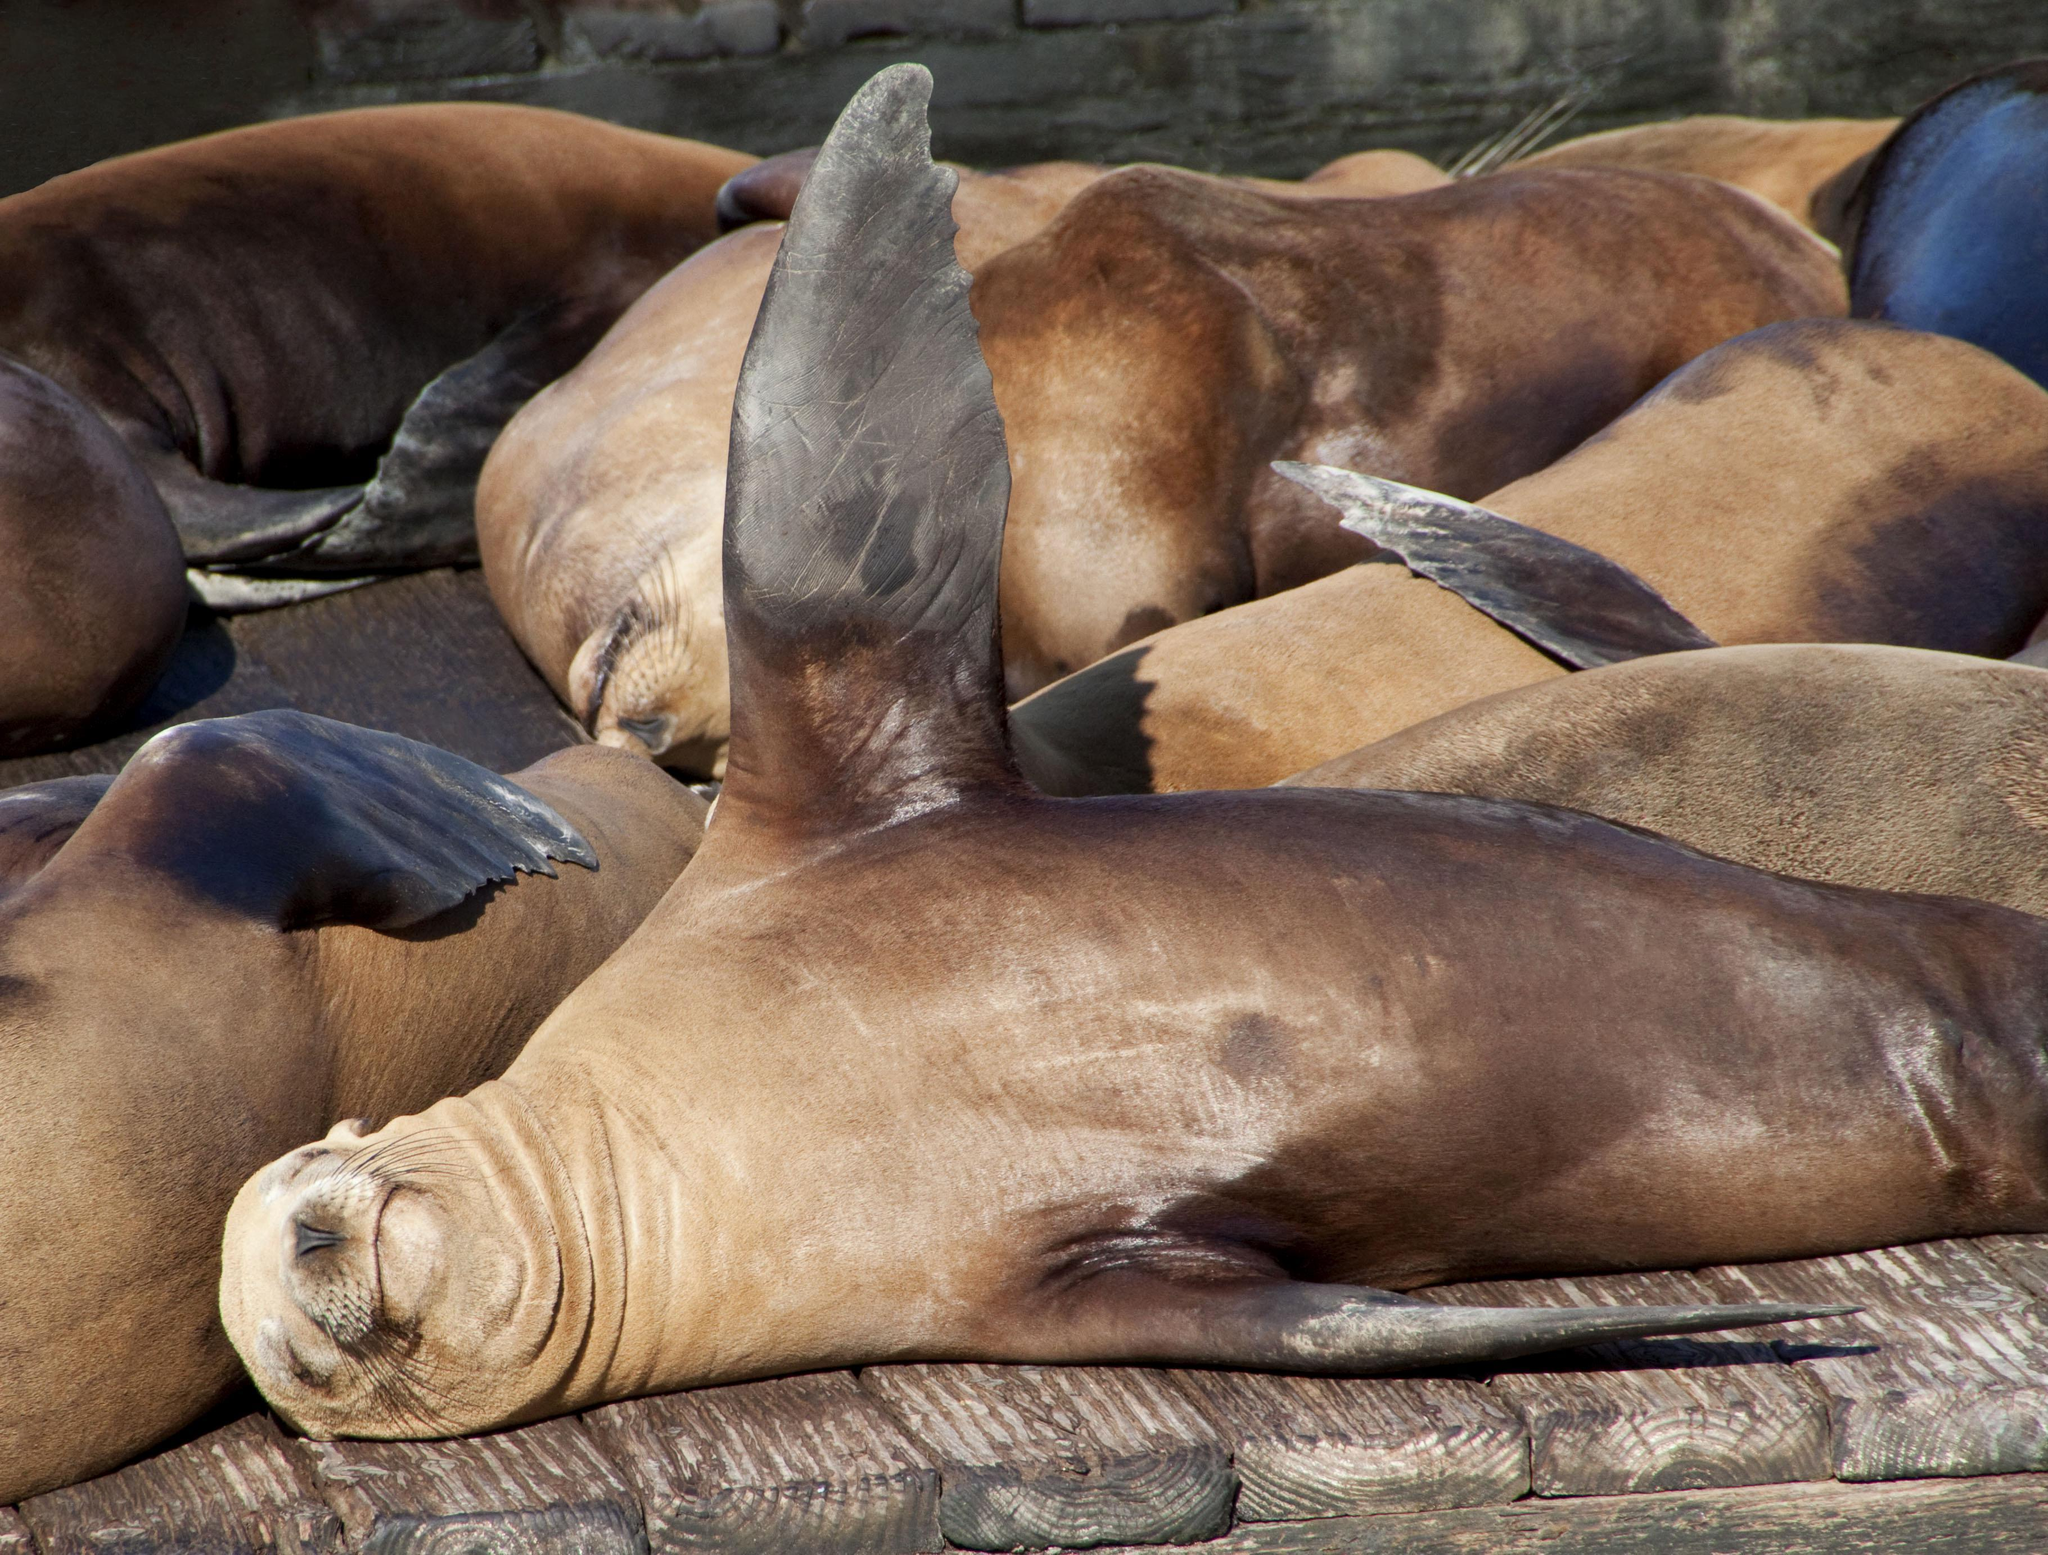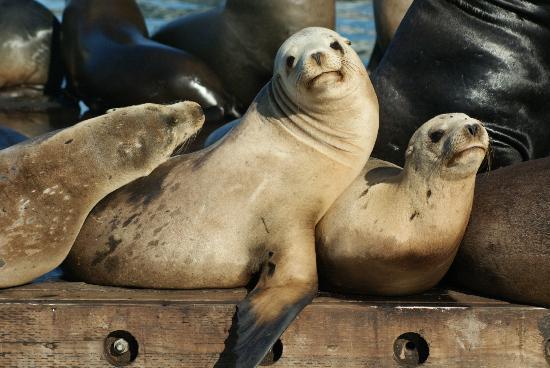The first image is the image on the left, the second image is the image on the right. For the images shown, is this caption "A black seal is sitting to the right of a brown seal." true? Answer yes or no. Yes. The first image is the image on the left, the second image is the image on the right. Examine the images to the left and right. Is the description "There are exactly two seals in the right image." accurate? Answer yes or no. No. 